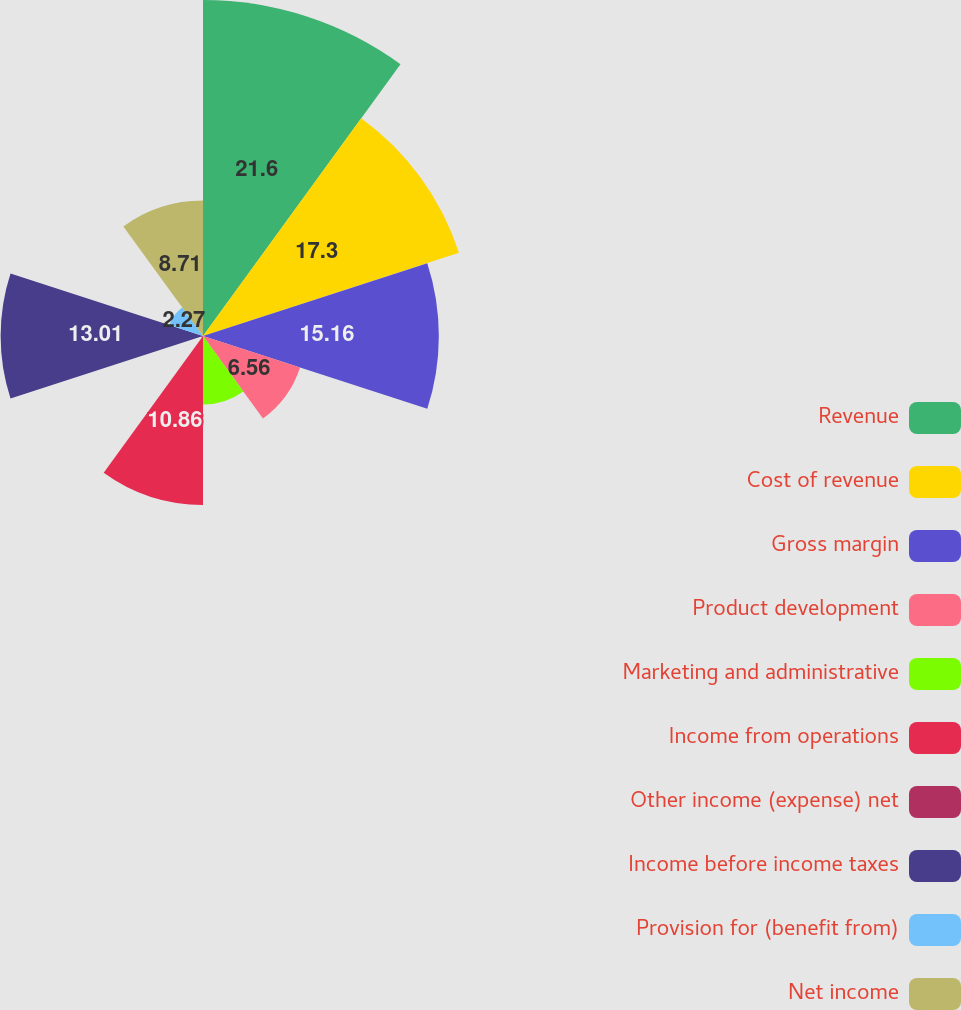<chart> <loc_0><loc_0><loc_500><loc_500><pie_chart><fcel>Revenue<fcel>Cost of revenue<fcel>Gross margin<fcel>Product development<fcel>Marketing and administrative<fcel>Income from operations<fcel>Other income (expense) net<fcel>Income before income taxes<fcel>Provision for (benefit from)<fcel>Net income<nl><fcel>21.6%<fcel>17.3%<fcel>15.16%<fcel>6.56%<fcel>4.41%<fcel>10.86%<fcel>0.12%<fcel>13.01%<fcel>2.27%<fcel>8.71%<nl></chart> 